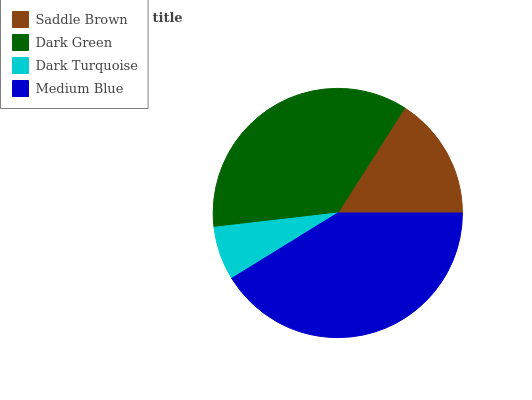Is Dark Turquoise the minimum?
Answer yes or no. Yes. Is Medium Blue the maximum?
Answer yes or no. Yes. Is Dark Green the minimum?
Answer yes or no. No. Is Dark Green the maximum?
Answer yes or no. No. Is Dark Green greater than Saddle Brown?
Answer yes or no. Yes. Is Saddle Brown less than Dark Green?
Answer yes or no. Yes. Is Saddle Brown greater than Dark Green?
Answer yes or no. No. Is Dark Green less than Saddle Brown?
Answer yes or no. No. Is Dark Green the high median?
Answer yes or no. Yes. Is Saddle Brown the low median?
Answer yes or no. Yes. Is Saddle Brown the high median?
Answer yes or no. No. Is Dark Turquoise the low median?
Answer yes or no. No. 